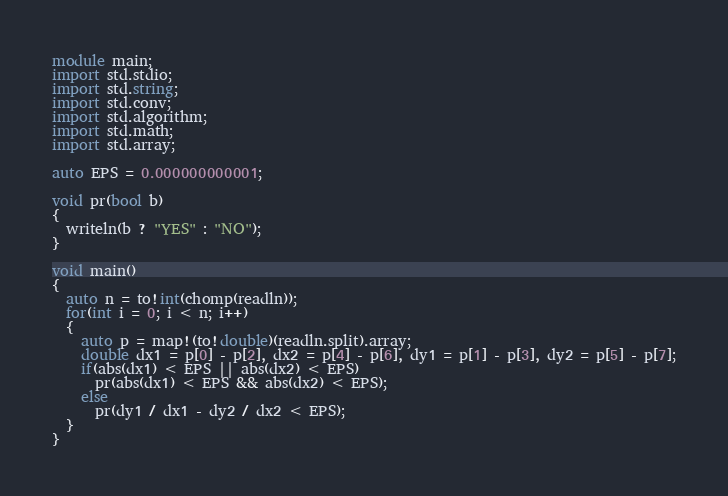Convert code to text. <code><loc_0><loc_0><loc_500><loc_500><_D_>module main;
import std.stdio;
import std.string;
import std.conv;
import std.algorithm;
import std.math;
import std.array;

auto EPS = 0.000000000001;

void pr(bool b)
{
  writeln(b ? "YES" : "NO");
}

void main()
{
  auto n = to!int(chomp(readln));
  for(int i = 0; i < n; i++)
  {
    auto p = map!(to!double)(readln.split).array;
    double dx1 = p[0] - p[2], dx2 = p[4] - p[6], dy1 = p[1] - p[3], dy2 = p[5] - p[7];
    if(abs(dx1) < EPS || abs(dx2) < EPS)
      pr(abs(dx1) < EPS && abs(dx2) < EPS);
    else
      pr(dy1 / dx1 - dy2 / dx2 < EPS); 
  }
}</code> 